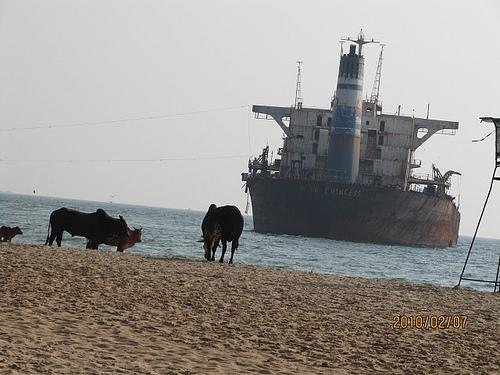What is visible in the water?

Choices:
A) snake
B) eel
C) boat
D) fish boat 